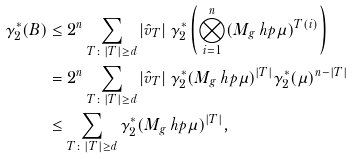<formula> <loc_0><loc_0><loc_500><loc_500>\gamma _ { 2 } ^ { * } ( B ) & \leq 2 ^ { n } \sum _ { T \colon | T | \geq d } | \hat { v } _ { T } | \ \gamma _ { 2 } ^ { * } \left ( \bigotimes _ { i = 1 } ^ { n } ( M _ { g } \ h p \mu ) ^ { T ( i ) } \right ) \\ & = 2 ^ { n } \sum _ { T \colon | T | \geq d } | \hat { v } _ { T } | \ \gamma _ { 2 } ^ { * } ( M _ { g } \ h p \mu ) ^ { | T | } \gamma _ { 2 } ^ { * } ( \mu ) ^ { n - | T | } \\ & \leq \sum _ { T \colon | T | \geq d } \gamma _ { 2 } ^ { * } ( M _ { g } \ h p \mu ) ^ { | T | } ,</formula> 